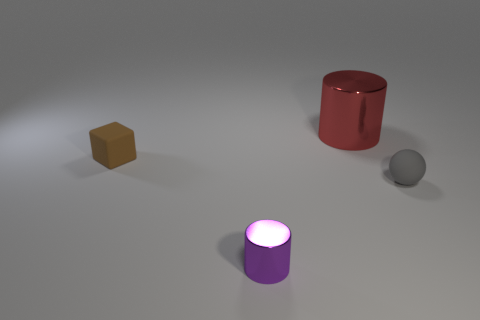There is a matte thing to the right of the tiny brown block; what is its color?
Keep it short and to the point. Gray. How many rubber objects are gray blocks or small purple cylinders?
Offer a very short reply. 0. What number of shiny things have the same size as the brown matte cube?
Offer a terse response. 1. There is a object that is both to the right of the tiny metallic cylinder and behind the tiny ball; what color is it?
Your answer should be very brief. Red. How many things are either big red rubber cylinders or gray rubber objects?
Your answer should be compact. 1. What number of tiny things are cylinders or rubber spheres?
Give a very brief answer. 2. Are there any other things that have the same color as the small metallic object?
Your response must be concise. No. There is a object that is both to the right of the small purple metallic cylinder and behind the gray sphere; what is its size?
Give a very brief answer. Large. How many other things are the same material as the gray ball?
Provide a short and direct response. 1. What shape is the object that is both left of the red object and to the right of the tiny brown rubber cube?
Ensure brevity in your answer.  Cylinder. 